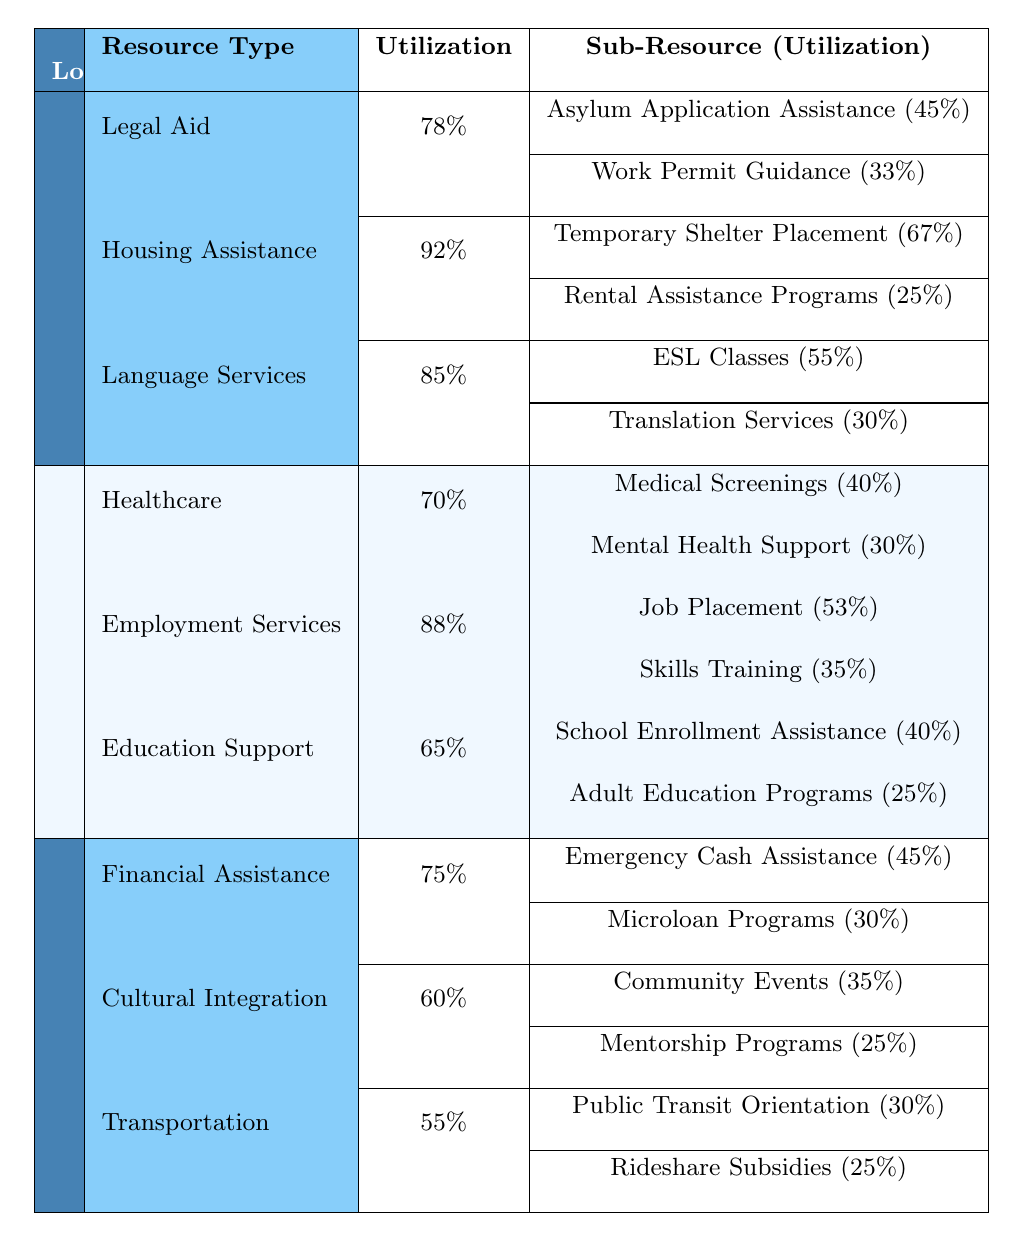What is the overall utilization rate for resources in New York City? In New York City, the resource utilization rates are Legal Aid (78%), Housing Assistance (92%), and Language Services (85%). To find the overall utilization, we average these three values: (78 + 92 + 85) / 3 = 85%.
Answer: 85% Which resource type has the highest utilization in Los Angeles? In Los Angeles, the resource types with their utilizations are Healthcare (70%), Employment Services (88%), and Education Support (65%). Employment Services has the highest utilization at 88%.
Answer: Employment Services What is the total utilization for all sub-resources under Housing Assistance in New York City? Under Housing Assistance in New York City, the sub-resources are Temporary Shelter Placement (67%) and Rental Assistance Programs (25%). Adding these yields a total of 67 + 25 = 92%.
Answer: 92% Is the utilization of Language Services in New York City greater than the utilization of Healthcare in Los Angeles? Language Services in New York City has a utilization of 85%, while Healthcare in Los Angeles has a utilization of 70%. Since 85% is greater than 70%, the statement is true.
Answer: Yes What is the average utilization of all resource types across the three locations? The utilizations across locations are: New York City (Legal Aid 78%, Housing Assistance 92%, Language Services 85%), Los Angeles (Healthcare 70%, Employment Services 88%, Education Support 65%), Miami (Financial Assistance 75%, Cultural Integration 60%, Transportation 55%). The average is calculated as: (78 + 92 + 85 + 70 + 88 + 65 + 75 + 60 + 55) / 9 = 74.67%.
Answer: 74.67% In Miami, which sub-resource under Cultural Integration has higher utilization? In Miami, the Cultural Integration sub-resources are Community Events (35%) and Mentorship Programs (25%). Community Events (35%) has a higher utilization than Mentorship Programs (25%).
Answer: Community Events What is the difference in utilization between the highest and lowest utilized resources in Los Angeles? In Los Angeles, Employment Services has the highest utilization at 88%, while Education Support has the lowest at 65%. The difference is calculated as 88 - 65 = 23%.
Answer: 23% What percentage of Language Services utilization corresponds to ESL Classes in New York City? In New York City, Language Services utilization is 85%, and ESL Classes utilization is 55%. The percentage of ESL Classes utilization relative to Language Services is (55 / 85) * 100 ≈ 64.71%.
Answer: 64.71% Which location has the highest total utilization rate considering all resources? Calculating total utilizations: New York City (78 + 92 + 85 = 255%), Los Angeles (70 + 88 + 65 = 223%), Miami (75 + 60 + 55 = 190%). New York City has the highest total utilization of 255%.
Answer: New York City Is it true that the utilization for Employment Services in Los Angeles surpasses 80%? The utilization for Employment Services in Los Angeles is 88%, which is greater than 80%. Therefore, the statement is true.
Answer: Yes What is the combined utilization of all sub-resources under Financial Assistance in Miami? The sub-resources under Financial Assistance in Miami are Emergency Cash Assistance (45%) and Microloan Programs (30%). Adding these percentages gives us 45 + 30 = 75%.
Answer: 75% 